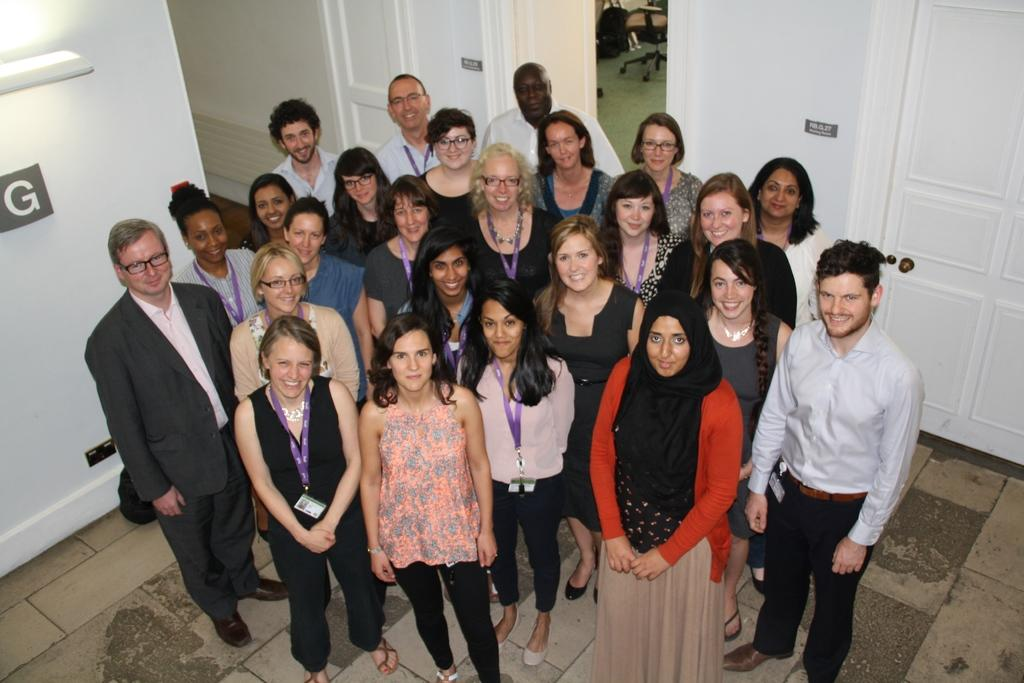What is the main focus of the image? The main focus of the image is the people in the center. What can be seen in the background of the image? There are doors and a chair in the background of the image. How many crows are sitting on the chair in the image? There are no crows present in the image; it only features people, doors, and a chair. 